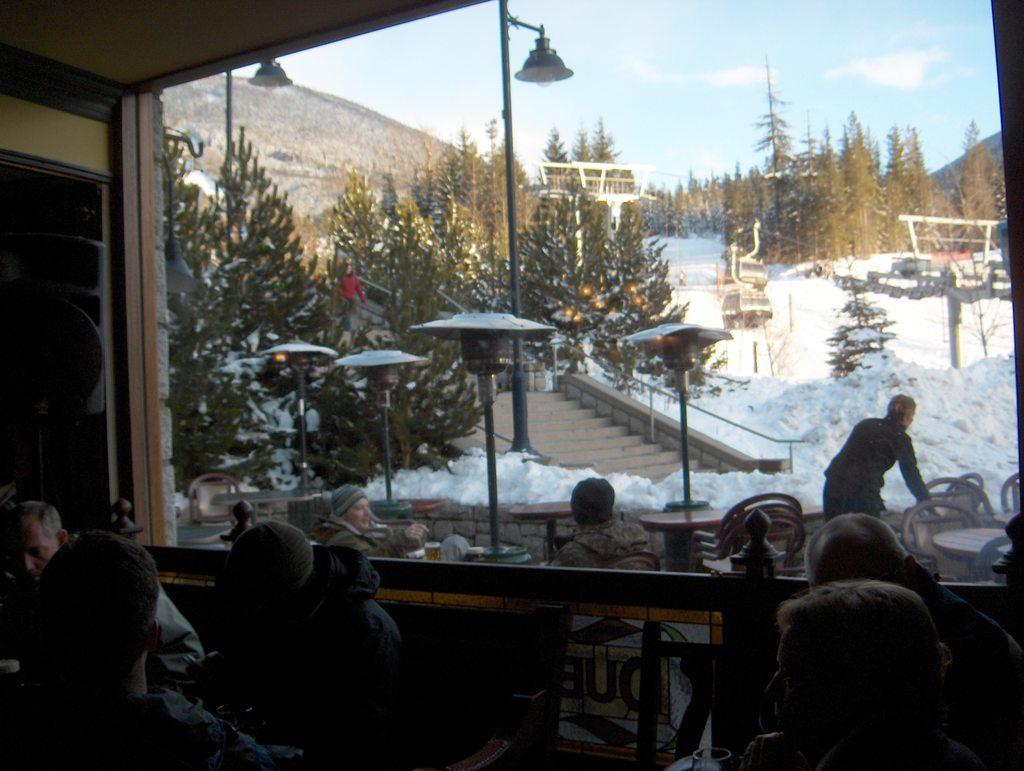Could you give a brief overview of what you see in this image? In this picture we can see the inside view of the restaurant. In the front there are some people sitting on the dining tables. Behind there are some trees and snow on the ground. In the background we can see some huge trees. 